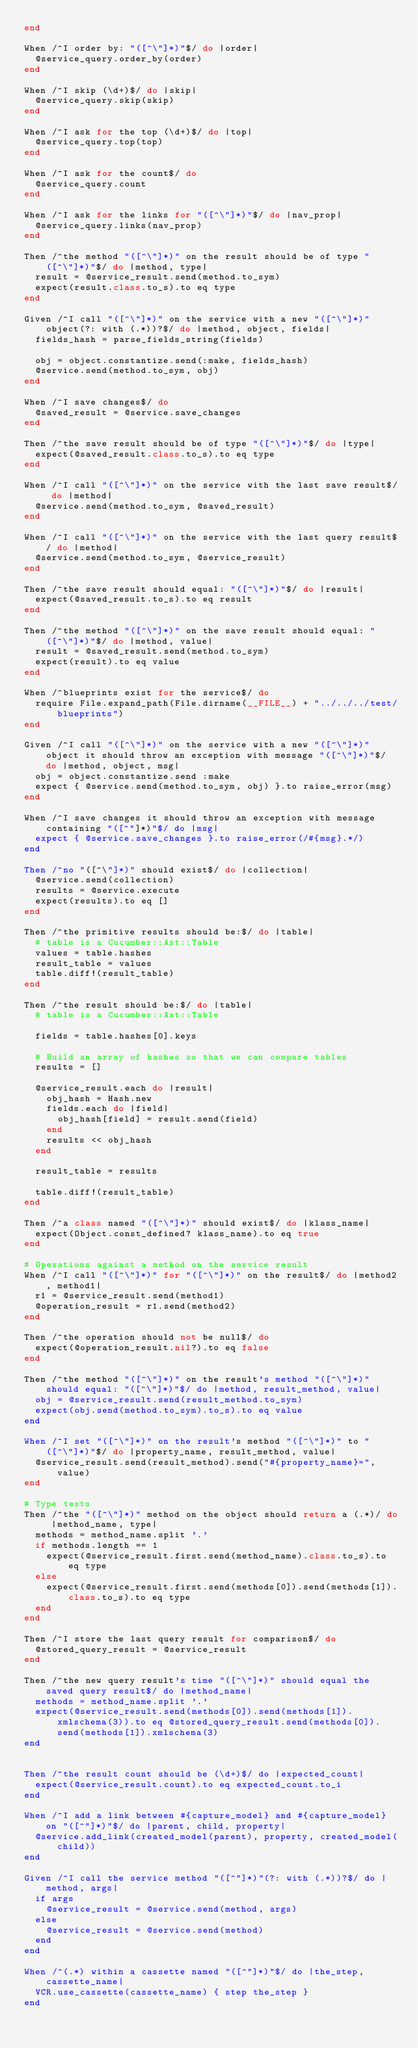<code> <loc_0><loc_0><loc_500><loc_500><_Ruby_>end

When /^I order by: "([^\"]*)"$/ do |order|
  @service_query.order_by(order)
end

When /^I skip (\d+)$/ do |skip|
  @service_query.skip(skip)
end

When /^I ask for the top (\d+)$/ do |top|
  @service_query.top(top)
end

When /^I ask for the count$/ do
  @service_query.count
end

When /^I ask for the links for "([^\"]*)"$/ do |nav_prop|
  @service_query.links(nav_prop)
end

Then /^the method "([^\"]*)" on the result should be of type "([^\"]*)"$/ do |method, type|
  result = @service_result.send(method.to_sym)
  expect(result.class.to_s).to eq type
end

Given /^I call "([^\"]*)" on the service with a new "([^\"]*)" object(?: with (.*))?$/ do |method, object, fields|
  fields_hash = parse_fields_string(fields)

  obj = object.constantize.send(:make, fields_hash)
  @service.send(method.to_sym, obj)
end

When /^I save changes$/ do
  @saved_result = @service.save_changes
end

Then /^the save result should be of type "([^\"]*)"$/ do |type|
  expect(@saved_result.class.to_s).to eq type
end

When /^I call "([^\"]*)" on the service with the last save result$/ do |method|
  @service.send(method.to_sym, @saved_result)
end

When /^I call "([^\"]*)" on the service with the last query result$/ do |method|
  @service.send(method.to_sym, @service_result)
end

Then /^the save result should equal: "([^\"]*)"$/ do |result|
  expect(@saved_result.to_s).to eq result
end

Then /^the method "([^\"]*)" on the save result should equal: "([^\"]*)"$/ do |method, value|
  result = @saved_result.send(method.to_sym)
  expect(result).to eq value
end

When /^blueprints exist for the service$/ do
  require File.expand_path(File.dirname(__FILE__) + "../../../test/blueprints")
end

Given /^I call "([^\"]*)" on the service with a new "([^\"]*)" object it should throw an exception with message "([^\"]*)"$/ do |method, object, msg|
  obj = object.constantize.send :make
  expect { @service.send(method.to_sym, obj) }.to raise_error(msg)
end

When /^I save changes it should throw an exception with message containing "([^"]*)"$/ do |msg|
  expect { @service.save_changes }.to raise_error(/#{msg}.*/)
end

Then /^no "([^\"]*)" should exist$/ do |collection|
  @service.send(collection)
  results = @service.execute
  expect(results).to eq []
end

Then /^the primitive results should be:$/ do |table|
  # table is a Cucumber::Ast::Table
  values = table.hashes
  result_table = values
  table.diff!(result_table)
end

Then /^the result should be:$/ do |table|
  # table is a Cucumber::Ast::Table

  fields = table.hashes[0].keys

  # Build an array of hashes so that we can compare tables
  results = []

  @service_result.each do |result|
    obj_hash = Hash.new
    fields.each do |field|
      obj_hash[field] = result.send(field)
    end
    results << obj_hash
  end

  result_table = results

  table.diff!(result_table)
end

Then /^a class named "([^\"]*)" should exist$/ do |klass_name|
  expect(Object.const_defined? klass_name).to eq true
end

# Operations against a method on the service result
When /^I call "([^\"]*)" for "([^\"]*)" on the result$/ do |method2, method1|
  r1 = @service_result.send(method1)
  @operation_result = r1.send(method2)
end

Then /^the operation should not be null$/ do
  expect(@operation_result.nil?).to eq false
end

Then /^the method "([^\"]*)" on the result's method "([^\"]*)" should equal: "([^\"]*)"$/ do |method, result_method, value|
  obj = @service_result.send(result_method.to_sym)
  expect(obj.send(method.to_sym).to_s).to eq value
end

When /^I set "([^\"]*)" on the result's method "([^\"]*)" to "([^\"]*)"$/ do |property_name, result_method, value|
  @service_result.send(result_method).send("#{property_name}=", value)
end

# Type tests
Then /^the "([^\"]*)" method on the object should return a (.*)/ do |method_name, type|
  methods = method_name.split '.'
  if methods.length == 1
    expect(@service_result.first.send(method_name).class.to_s).to eq type
  else
    expect(@service_result.first.send(methods[0]).send(methods[1]).class.to_s).to eq type
  end
end

Then /^I store the last query result for comparison$/ do
  @stored_query_result = @service_result
end

Then /^the new query result's time "([^\"]*)" should equal the saved query result$/ do |method_name|
  methods = method_name.split '.'
  expect(@service_result.send(methods[0]).send(methods[1]).xmlschema(3)).to eq @stored_query_result.send(methods[0]).send(methods[1]).xmlschema(3)
end


Then /^the result count should be (\d+)$/ do |expected_count|
  expect(@service_result.count).to eq expected_count.to_i
end

When /^I add a link between #{capture_model} and #{capture_model} on "([^"]*)"$/ do |parent, child, property|
  @service.add_link(created_model(parent), property, created_model(child))
end

Given /^I call the service method "([^"]*)"(?: with (.*))?$/ do |method, args|
  if args
    @service_result = @service.send(method, args)
  else
    @service_result = @service.send(method)
  end
end

When /^(.*) within a cassette named "([^"]*)"$/ do |the_step, cassette_name|
  VCR.use_cassette(cassette_name) { step the_step }
end
</code> 